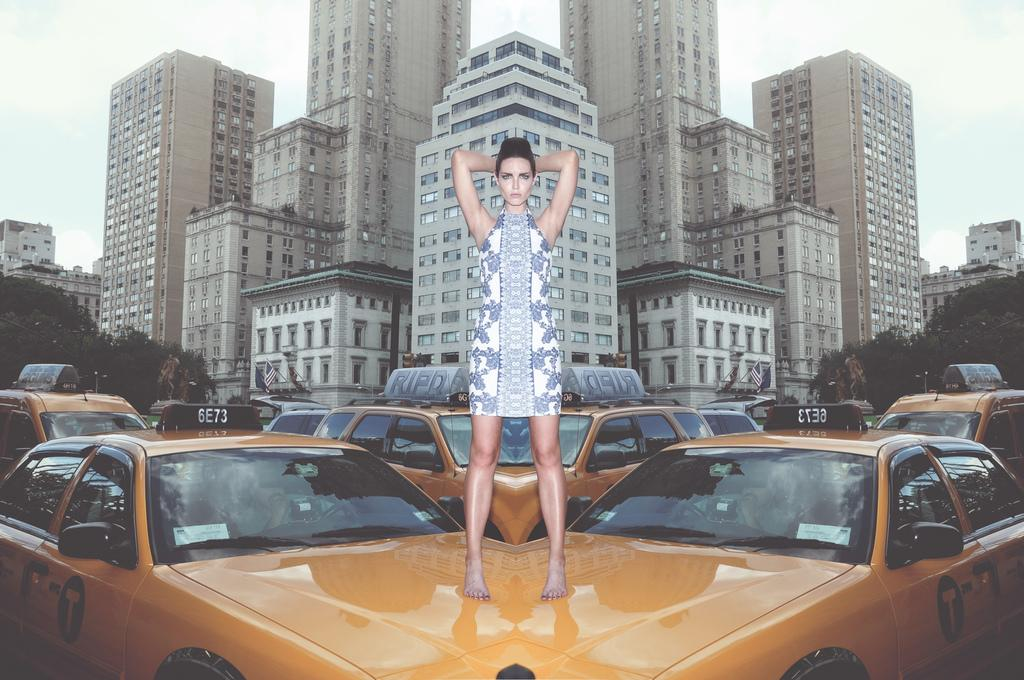<image>
Describe the image concisely. A woman standing on a taxi that has a sign with 6E73 on it. 